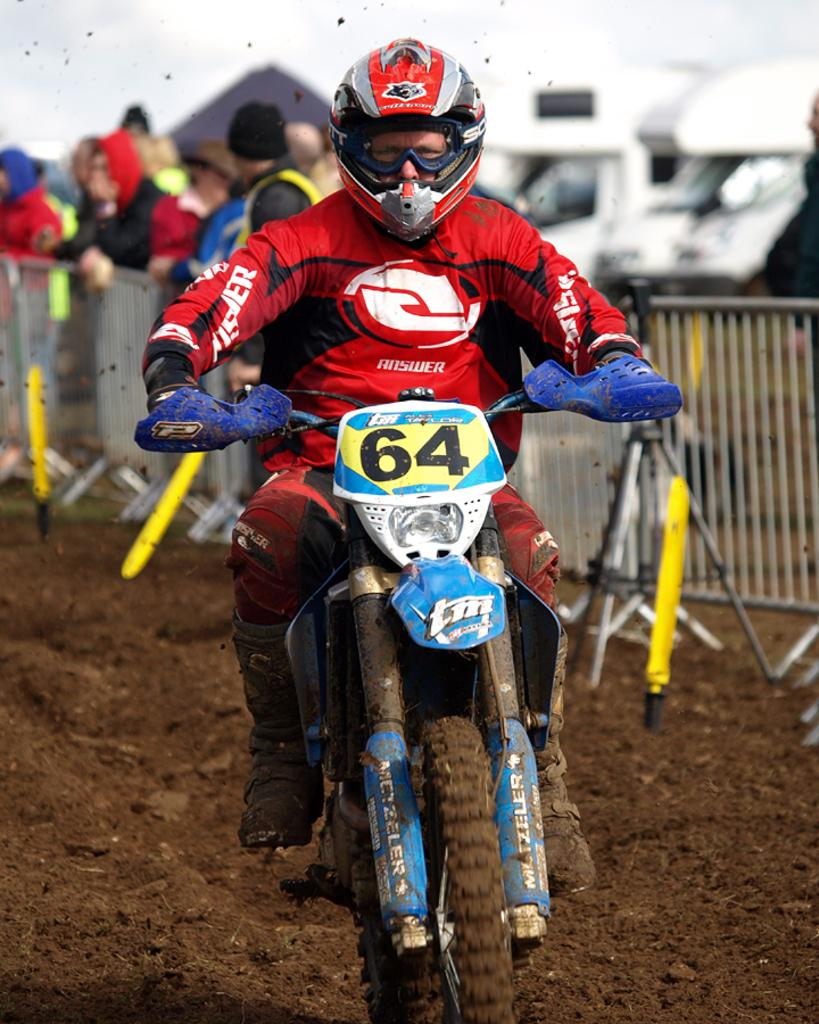What is the main subject of the image? The main subject of the image is a person riding a bike. Are there any other people in the image? Yes, there are people standing at the back side of the bike. What are these people holding? These people are holding a grill. What type of dress is the bike wearing in the image? The bike is not wearing a dress, as it is an inanimate object and does not have the ability to wear clothing. 